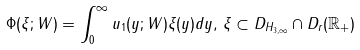Convert formula to latex. <formula><loc_0><loc_0><loc_500><loc_500>\Phi ( \xi ; W ) = \int _ { 0 } ^ { \infty } u _ { 1 } ( y ; W ) \xi ( y ) d y , \, \xi \subset D _ { H _ { 3 , \infty } } \cap D _ { r } ( \mathbb { R } _ { + } )</formula> 